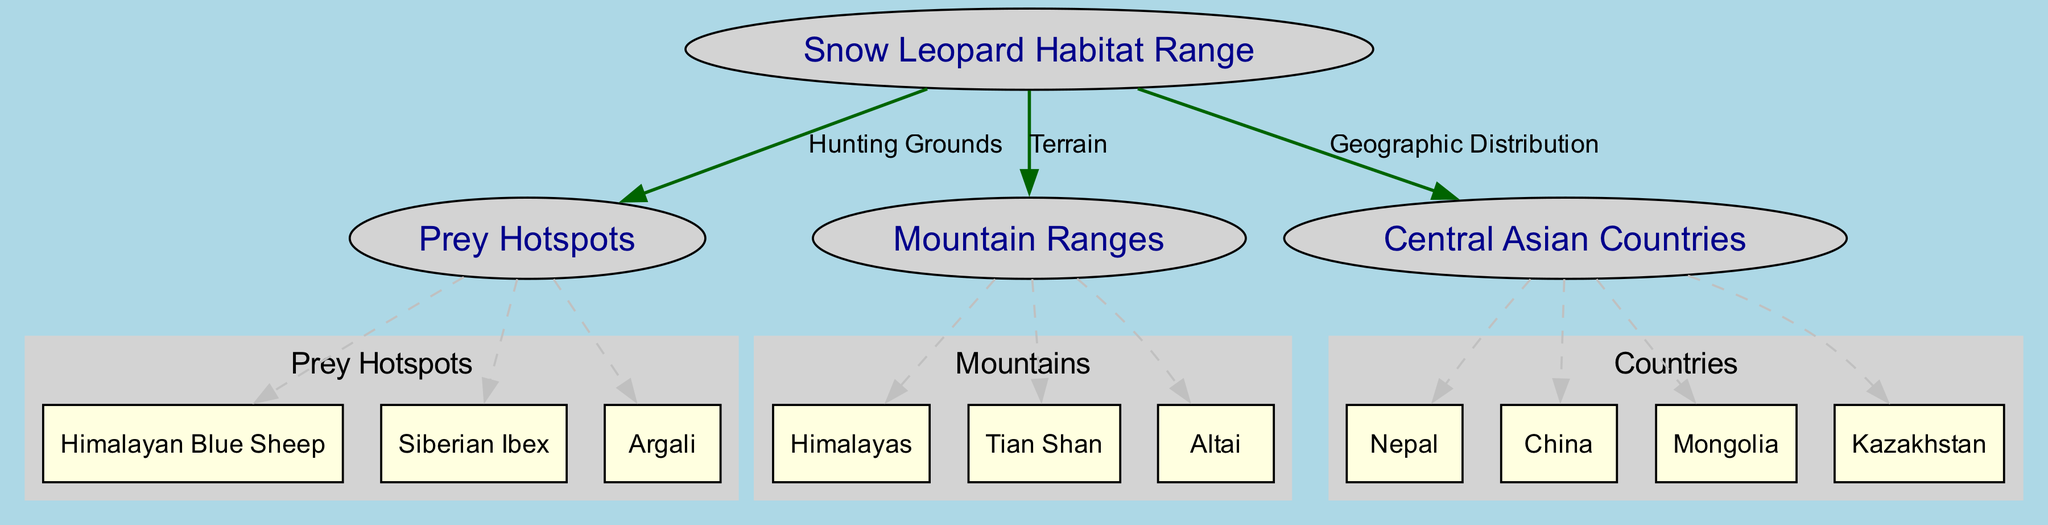What is highlighted in the diagram as the hunting grounds for snow leopards? The diagram indicates "Prey Hotspots" as the hunting grounds linked to the snow leopard habitat range. This shows where snow leopards find their food.
Answer: Prey Hotspots Which mountain range is included in the snow leopard habitat? The diagram specifies several mountain ranges; one of them is the "Himalayas," which is known to be part of the snow leopard's natural habitat.
Answer: Himalayas How many countries are indicated in the geographic distribution of snow leopards? The diagram lists four countries: Nepal, China, Mongolia, and Kazakhstan, which form the geographic distribution of the snow leopard habitat.
Answer: Four What type of species are identified under prey hotspots? The "Himalayan Blue Sheep," "Siberian Ibex," and "Argali" are mentioned in the diagram, indicating the types of prey that snow leopards hunt.
Answer: Himalayan Blue Sheep, Siberian Ibex, Argali Which two edges represent the relationship between nodes in the diagram? Two edges in the diagram connect the nodes representing "Hunting Grounds" and "Terrain," highlighting important relationships essential for understanding snow leopard habitat.
Answer: Hunting Grounds, Terrain In which geographic area are the prey hotspots located according to the diagram? The prey hotspots are collectively located within the snow leopard habitat range, which spans several mountainous regions noted in the diagram.
Answer: Snow Leopard Habitat Range What are the three specific mountain ranges noted in the diagram? The diagram lists "Himalayas," "Tian Shan," and "Altai" as the specific mountain ranges that are part of the snow leopard habitat.
Answer: Himalayas, Tian Shan, Altai Which node summarizes the geographic distribution of snow leopards? The geographic distribution of snow leopards is summarized by the node labeled "Central Asian Countries," which provides context for where they can be found.
Answer: Central Asian Countries What is the relationship between prey hotspots and habitat range? The relationship is depicted as "Hunting Grounds," which signifies that these hotspots are critical for the snow leopards' survival.
Answer: Hunting Grounds 